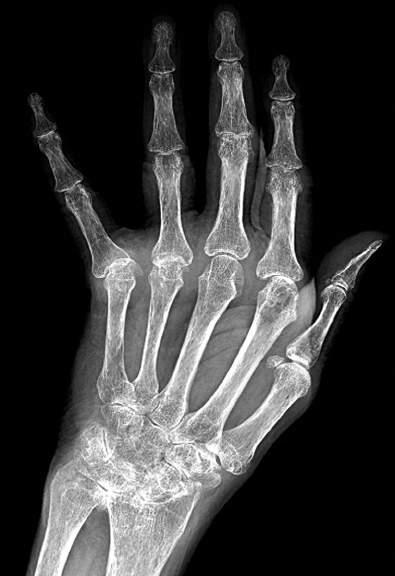do both adrenal glands include diffuse osteopenia, marked loss of the joint spaces of the carpal, metacarpal, phalangeal, and interphalangeal joints, periarticular bony erosions, and ulnar drift of the fingers?
Answer the question using a single word or phrase. No 